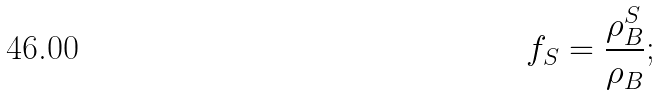Convert formula to latex. <formula><loc_0><loc_0><loc_500><loc_500>f _ { S } = \frac { \rho _ { B } ^ { S } } { \rho _ { B } } ;</formula> 